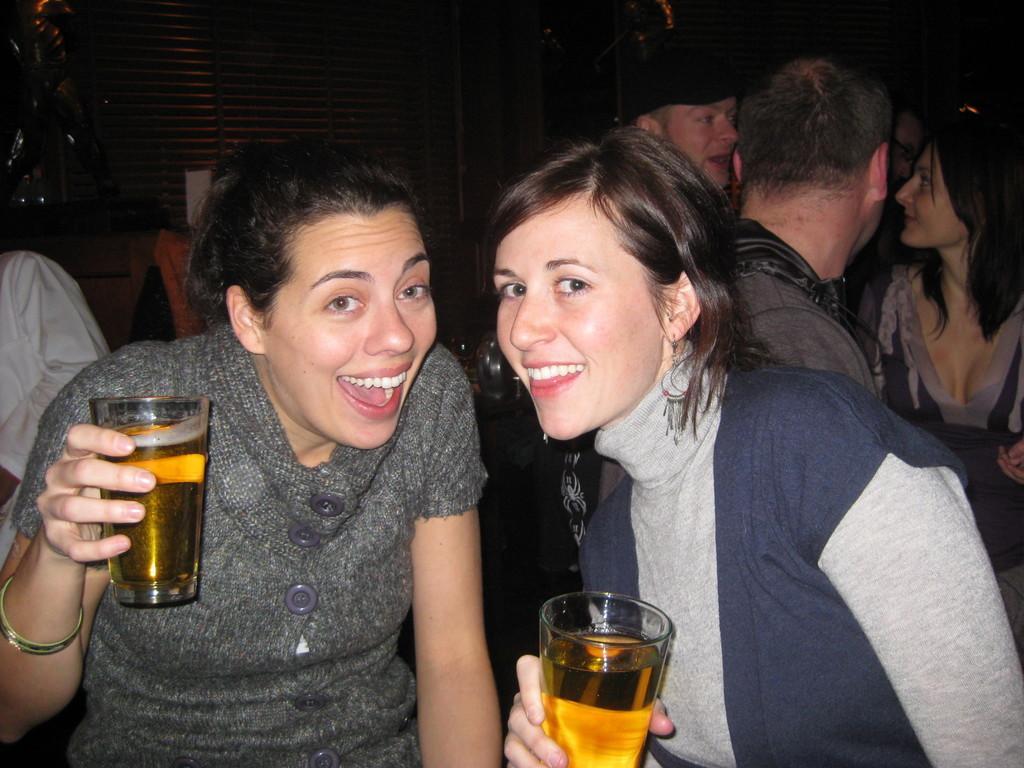Could you give a brief overview of what you see in this image? In this image there are a group of people in the foreground there are two women who are holding glasses, in that glasses there is some drink. In the background there is a wall and some objects. 